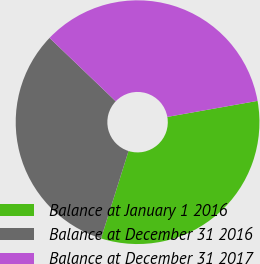Convert chart to OTSL. <chart><loc_0><loc_0><loc_500><loc_500><pie_chart><fcel>Balance at January 1 2016<fcel>Balance at December 31 2016<fcel>Balance at December 31 2017<nl><fcel>32.64%<fcel>32.31%<fcel>35.05%<nl></chart> 